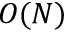<formula> <loc_0><loc_0><loc_500><loc_500>O ( N )</formula> 